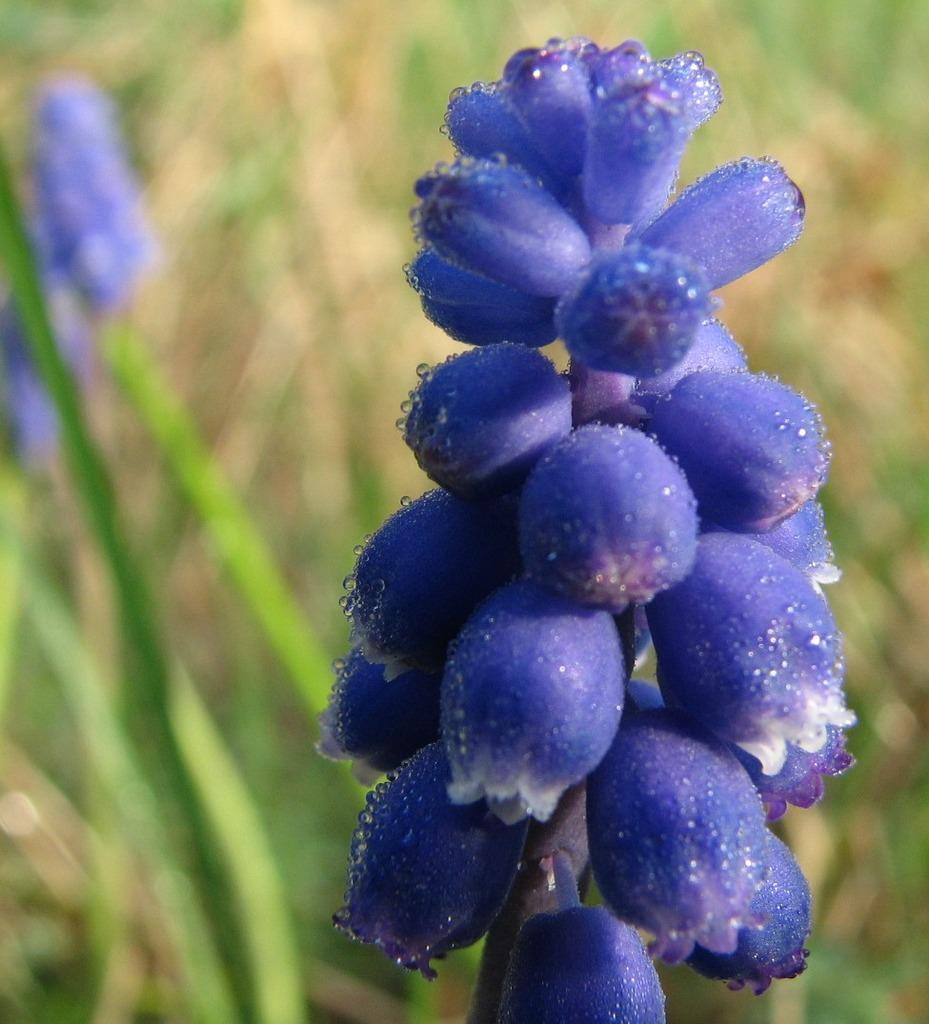What type of plant is located on the left side of the image? There is a flower plant on the left side of the image. What color is the flower plant? The flower plant is purple in color. Can you describe the plants in the background of the image? There are other plants in the background of the image. Can you tell me how much the receipt costs in the image? There is no receipt present in the image, so it is not possible to determine its cost. 